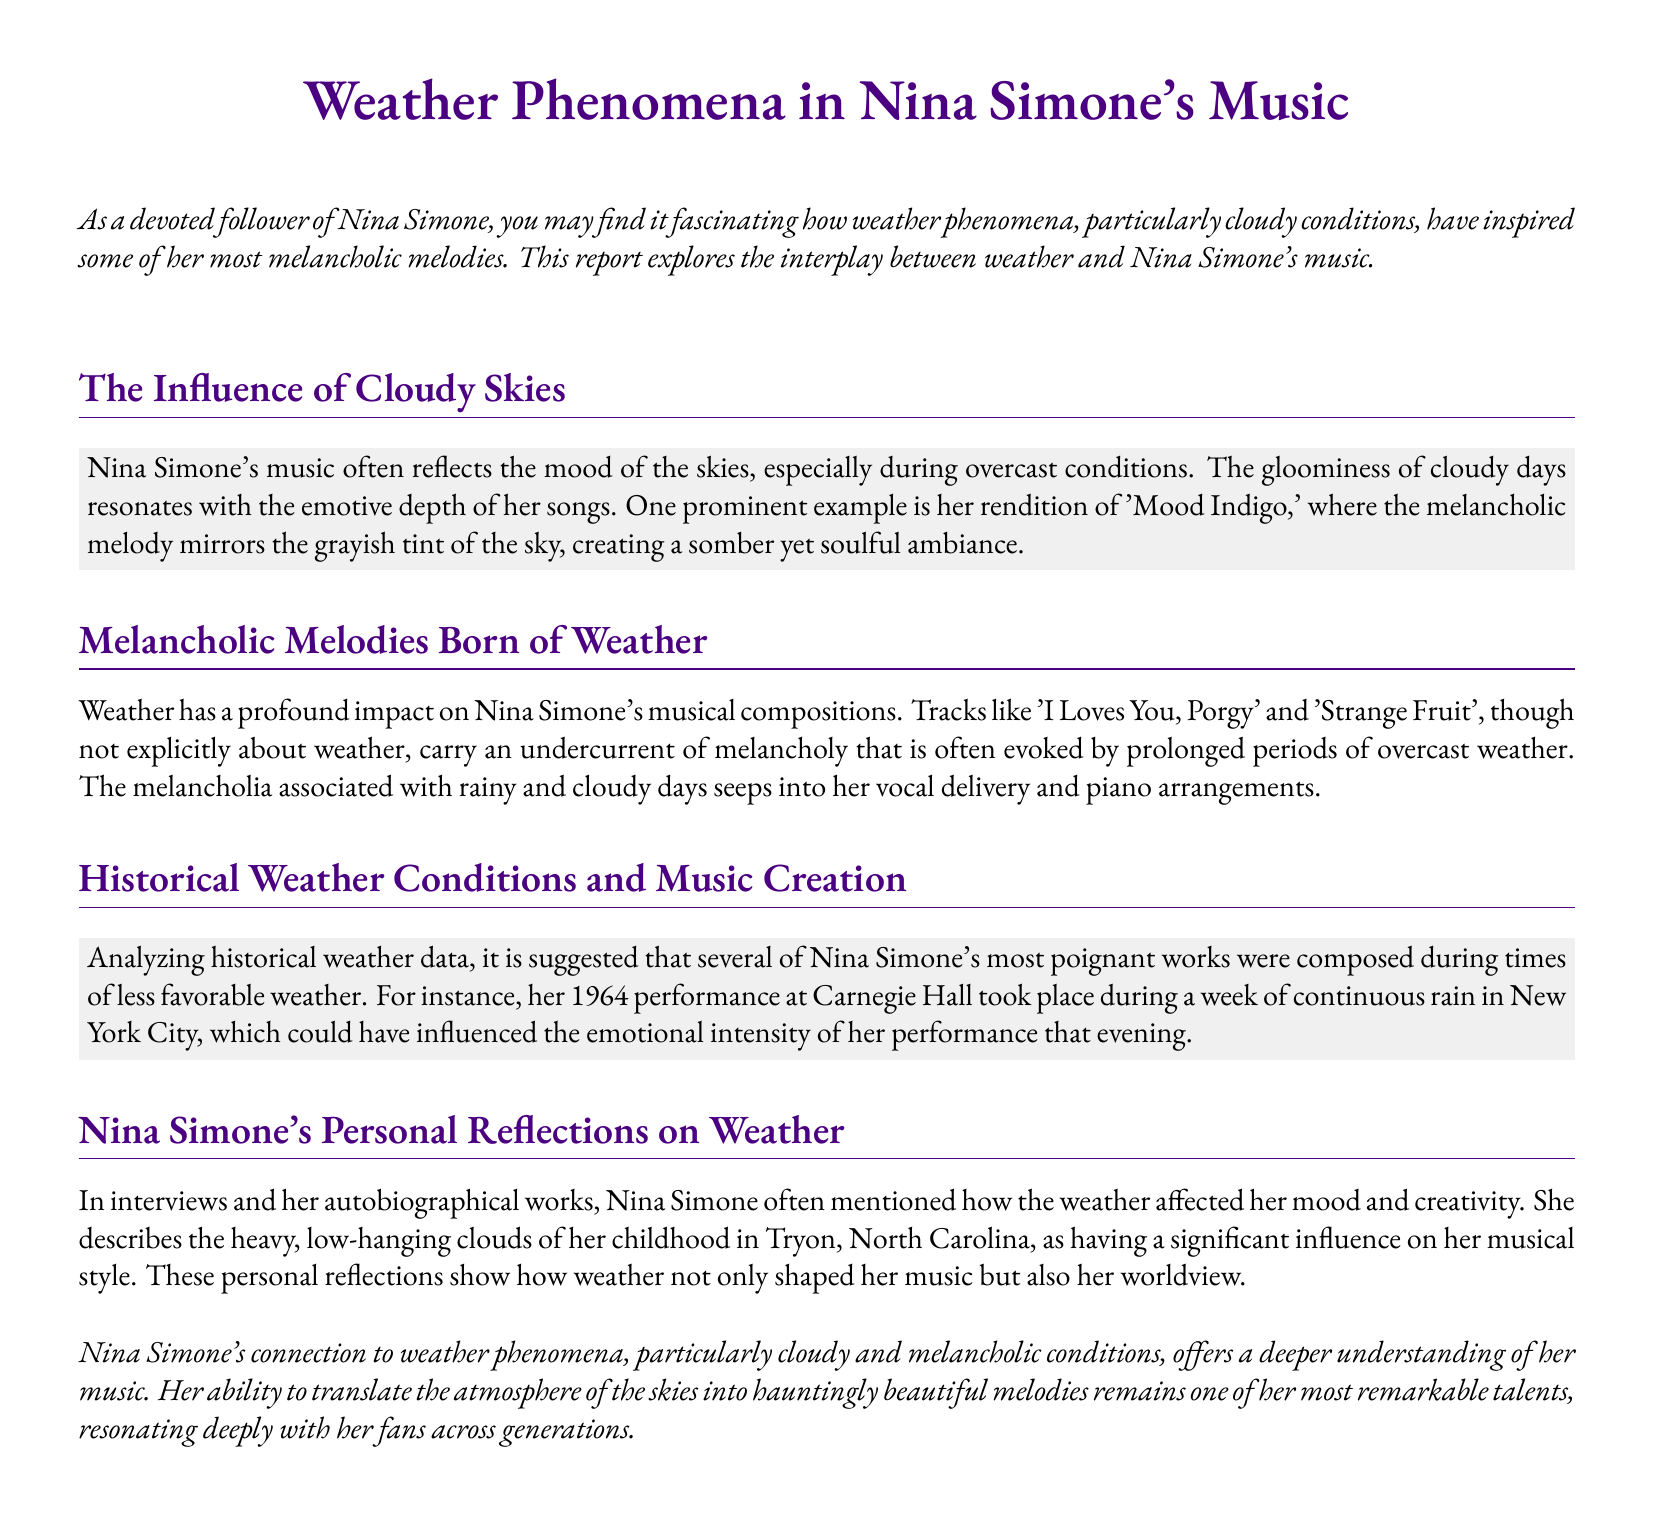What is the main theme of the document? The main theme discusses how weather phenomena, specifically cloudy conditions, inspire Nina Simone's music.
Answer: Weather phenomena Which song is mentioned as reflecting gloomy weather? The song 'Mood Indigo' is highlighted as mirroring the grayish tint of cloudy skies.
Answer: Mood Indigo What impact does weather have on Nina Simone's music according to the document? Weather influences the emotional depth and melancholy present in her musical compositions.
Answer: Emotional depth During which year did Nina Simone perform at Carnegie Hall? The document references her performance occurring in 1964.
Answer: 1964 Where was Nina Simone's childhood spent, influencing her music? Nina Simone describes her childhood in Tryon, North Carolina, as impactful to her musical style.
Answer: Tryon, North Carolina What type of weather is suggested to have influenced some of her poignant works? The document suggests that less favorable weather, including continuous rain, influenced her works.
Answer: Continuous rain What specific emotional quality is associated with Nina Simone's songs during cloudy days? The melancholic quality of Nina Simone's songs is emphasized, linking it to cloudy weather.
Answer: Melancholic What musical elements are suggested to be influenced by weather? Nina Simone's vocal delivery and piano arrangements are noted as influenced by weather.
Answer: Vocal delivery and piano arrangements 